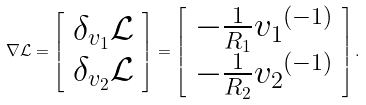<formula> <loc_0><loc_0><loc_500><loc_500>\nabla \mathcal { L } = \left [ \begin{array} { c } \delta _ { v _ { 1 } } \mathcal { L } \\ \delta _ { v _ { 2 } } \mathcal { L } \\ \end{array} \right ] = \left [ \begin{array} { c } - \frac { 1 } { R _ { 1 } } { v _ { 1 } } ^ { \left ( - 1 \right ) } \\ - \frac { 1 } { R _ { 2 } } { v _ { 2 } } ^ { \left ( - 1 \right ) } \\ \end{array} \right ] .</formula> 